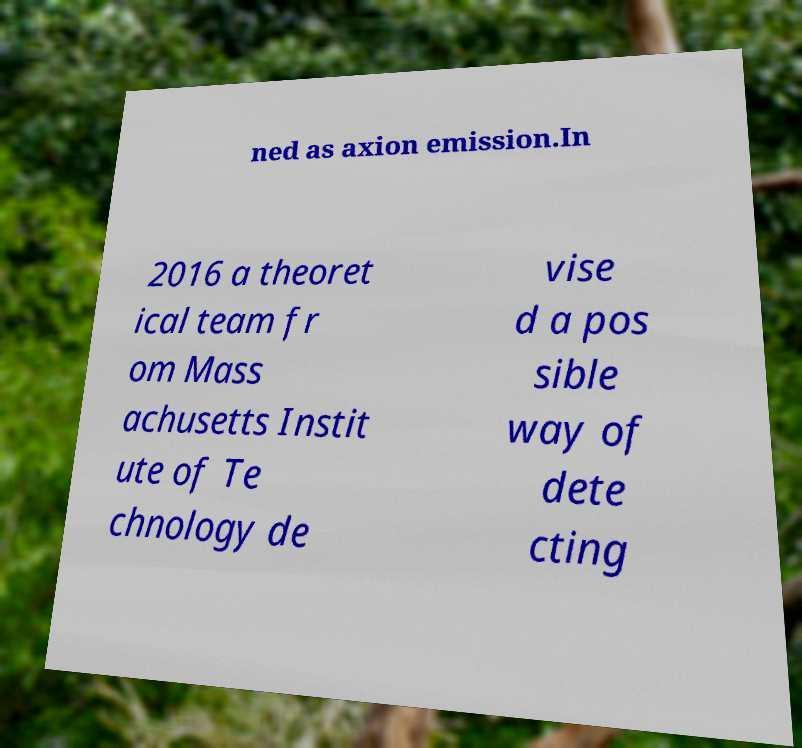Please read and relay the text visible in this image. What does it say? ned as axion emission.In 2016 a theoret ical team fr om Mass achusetts Instit ute of Te chnology de vise d a pos sible way of dete cting 